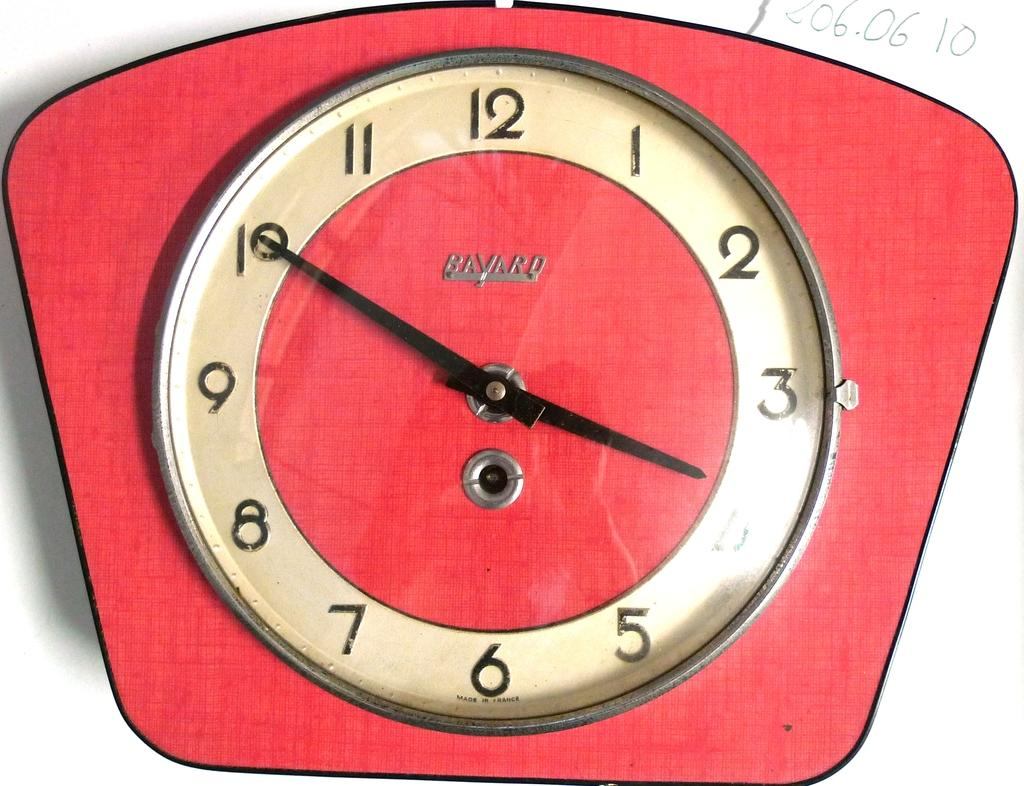<image>
Offer a succinct explanation of the picture presented. A clock by Bavard shows the time is 3:50. 